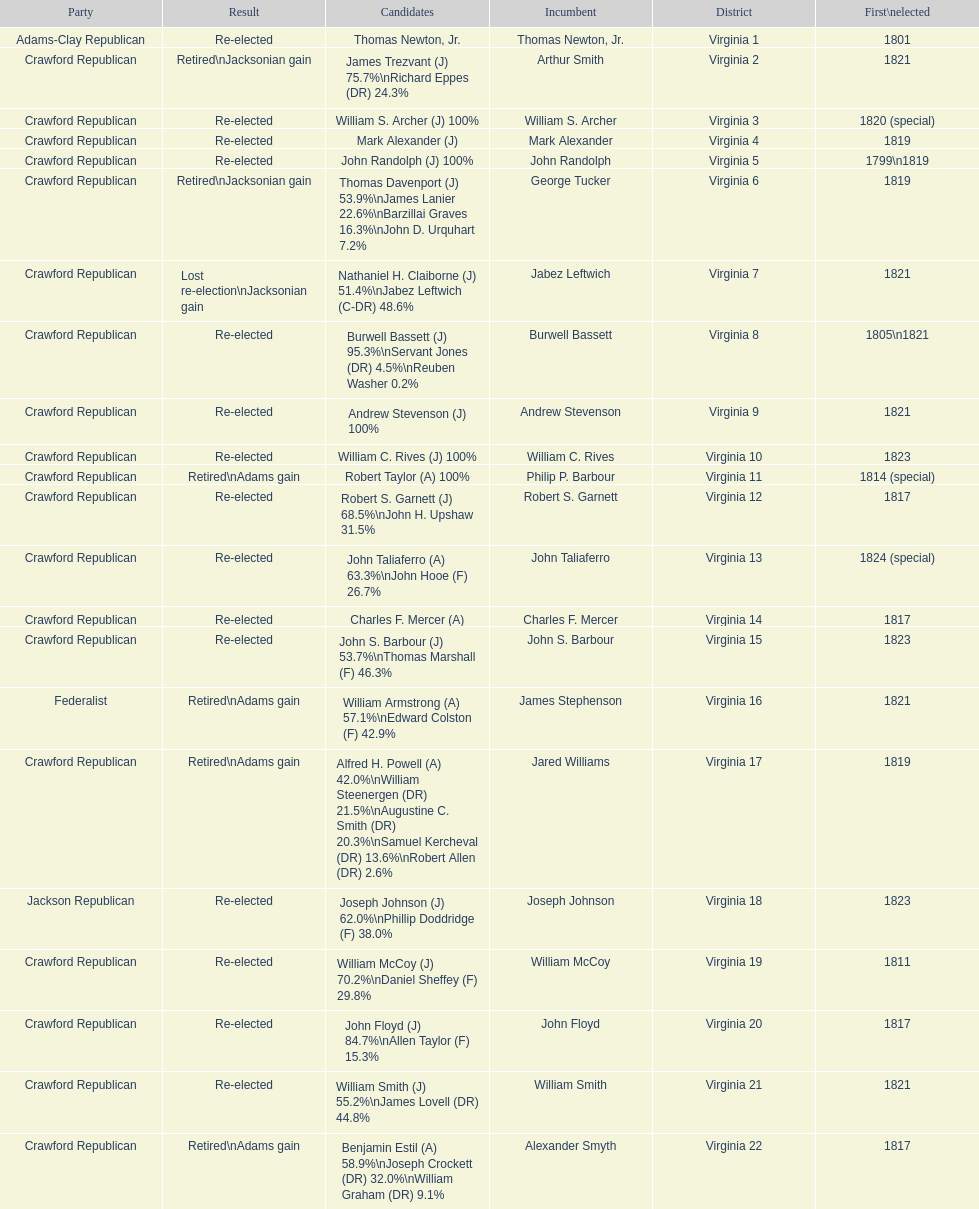Which incumbents belonged to the crawford republican party? Arthur Smith, William S. Archer, Mark Alexander, John Randolph, George Tucker, Jabez Leftwich, Burwell Bassett, Andrew Stevenson, William C. Rives, Philip P. Barbour, Robert S. Garnett, John Taliaferro, Charles F. Mercer, John S. Barbour, Jared Williams, William McCoy, John Floyd, William Smith, Alexander Smyth. Which of these incumbents were first elected in 1821? Arthur Smith, Jabez Leftwich, Andrew Stevenson, William Smith. Which of these incumbents have a last name of smith? Arthur Smith, William Smith. Which of these two were not re-elected? Arthur Smith. 